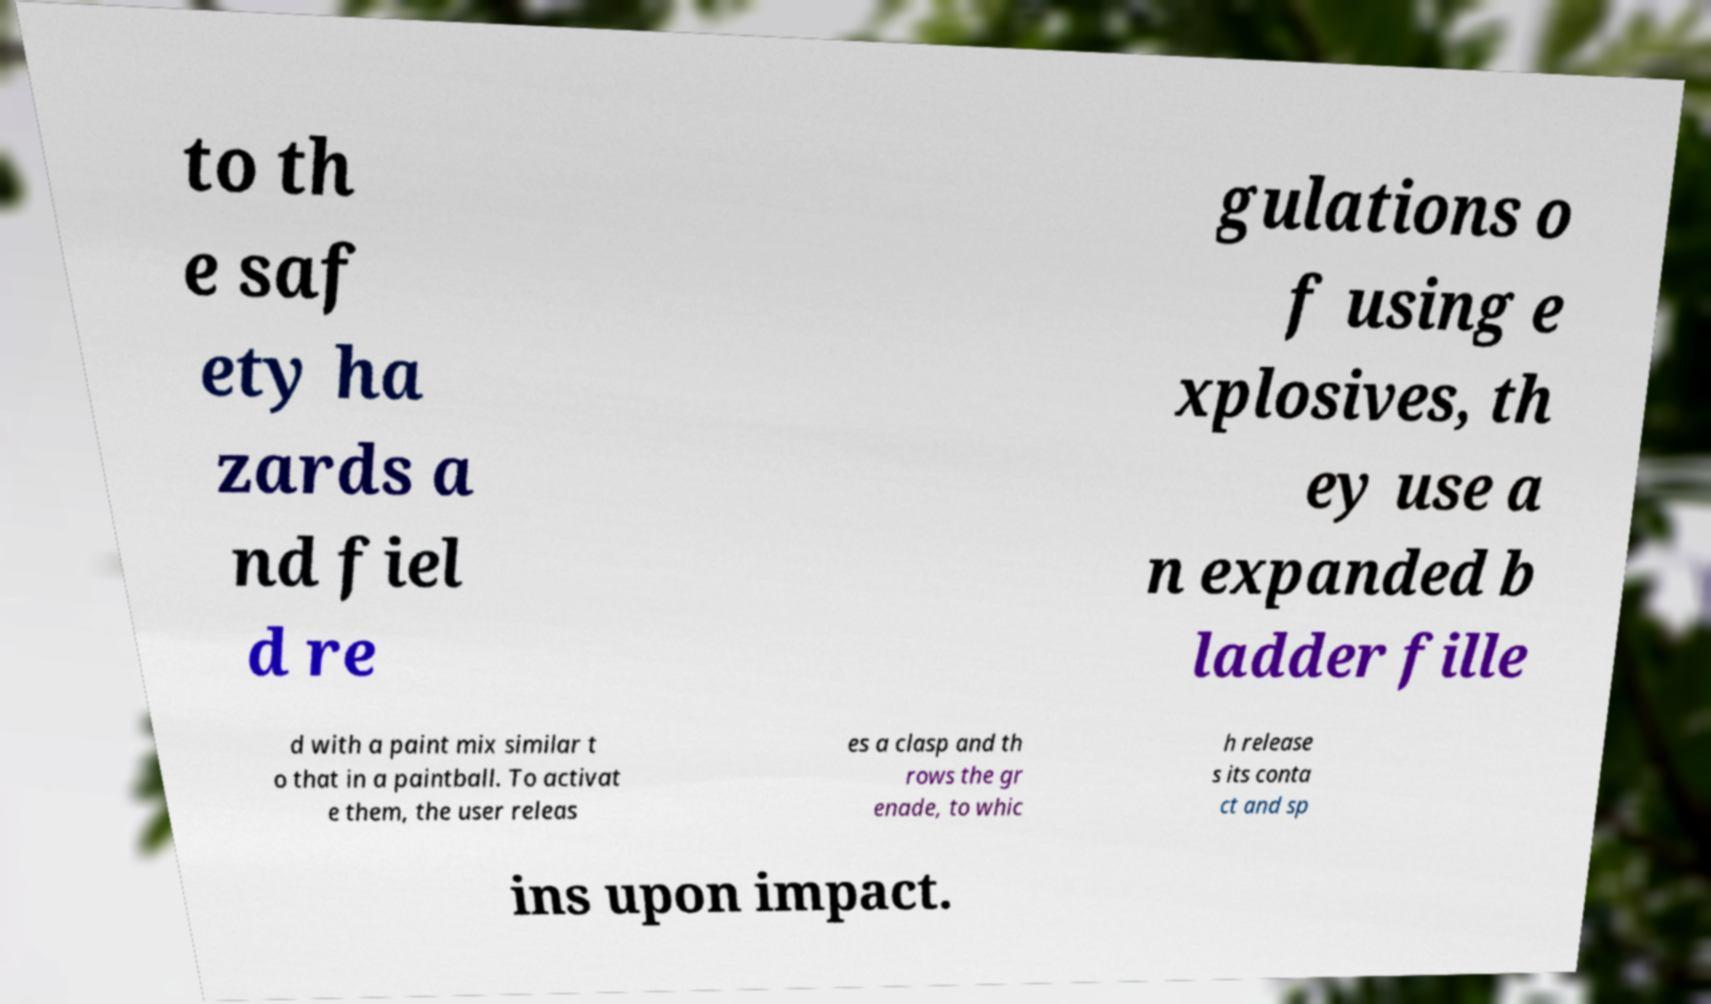Can you accurately transcribe the text from the provided image for me? to th e saf ety ha zards a nd fiel d re gulations o f using e xplosives, th ey use a n expanded b ladder fille d with a paint mix similar t o that in a paintball. To activat e them, the user releas es a clasp and th rows the gr enade, to whic h release s its conta ct and sp ins upon impact. 